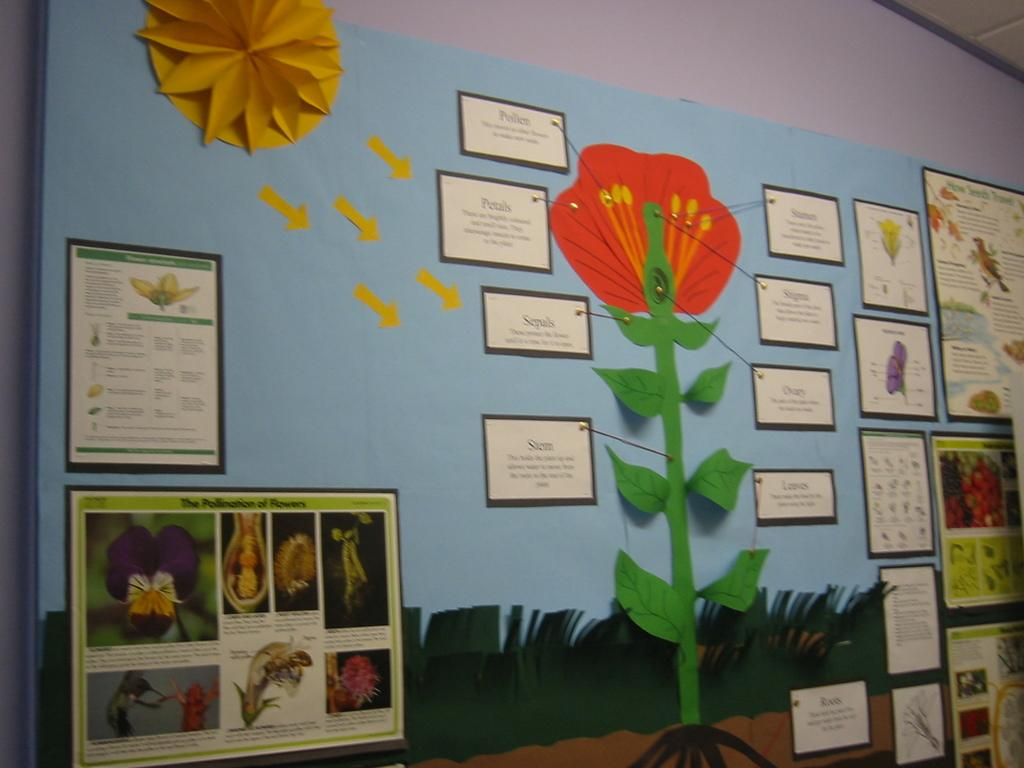What is the main subject in the center of the image? There is a chart in the center of the image. What is depicted on the chart? The chart contains flowers. Is there any text on the chart? Yes, there is text on the chart. What can be seen in the background of the image? There is a wall in the background of the image. How many ants can be seen crawling on the cars in the image? There are no ants or cars present in the image; it features a chart with flowers and text. What type of treatment is being administered to the flowers in the image? There is no treatment being administered to the flowers in the image; the chart simply displays them. 